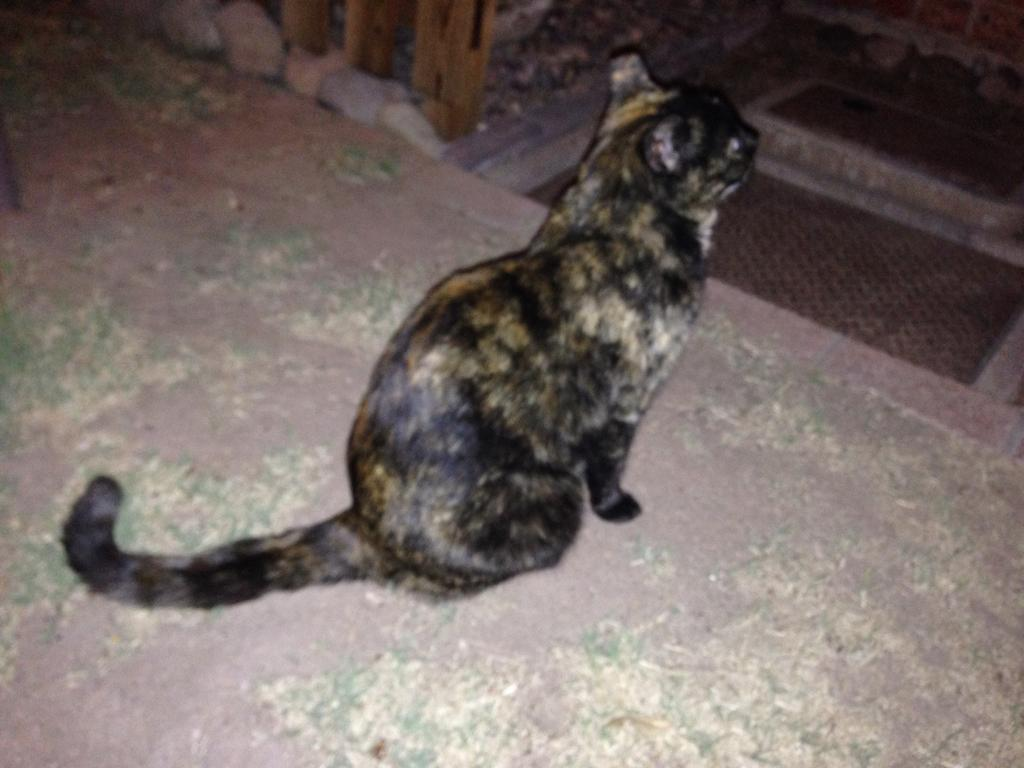What animal is present on the ground in the image? There is a cat on the ground in the image. What type of natural elements can be seen in the image? There are stones visible in the image. Can you identify any man-made objects in the image? There might be a grill in the image. What does the queen taste like in the image? There is no queen present in the image, and therefore no taste can be associated with her. 